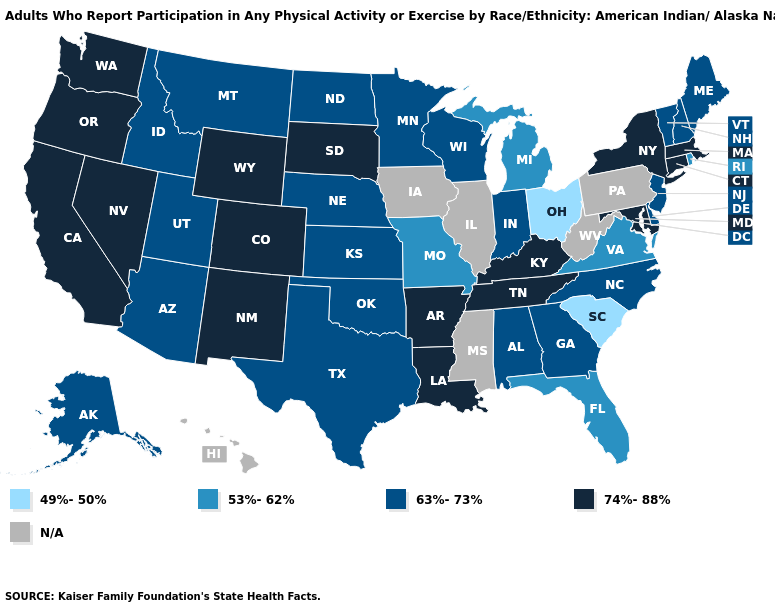What is the value of Alaska?
Be succinct. 63%-73%. What is the value of Massachusetts?
Concise answer only. 74%-88%. Does Michigan have the lowest value in the USA?
Keep it brief. No. Does Washington have the lowest value in the West?
Answer briefly. No. Does Ohio have the lowest value in the USA?
Give a very brief answer. Yes. Name the states that have a value in the range N/A?
Keep it brief. Hawaii, Illinois, Iowa, Mississippi, Pennsylvania, West Virginia. What is the value of Nevada?
Keep it brief. 74%-88%. Name the states that have a value in the range 74%-88%?
Short answer required. Arkansas, California, Colorado, Connecticut, Kentucky, Louisiana, Maryland, Massachusetts, Nevada, New Mexico, New York, Oregon, South Dakota, Tennessee, Washington, Wyoming. What is the highest value in states that border New Jersey?
Concise answer only. 74%-88%. Name the states that have a value in the range 49%-50%?
Keep it brief. Ohio, South Carolina. Name the states that have a value in the range 49%-50%?
Be succinct. Ohio, South Carolina. Among the states that border North Dakota , which have the highest value?
Short answer required. South Dakota. Which states have the lowest value in the South?
Write a very short answer. South Carolina. 